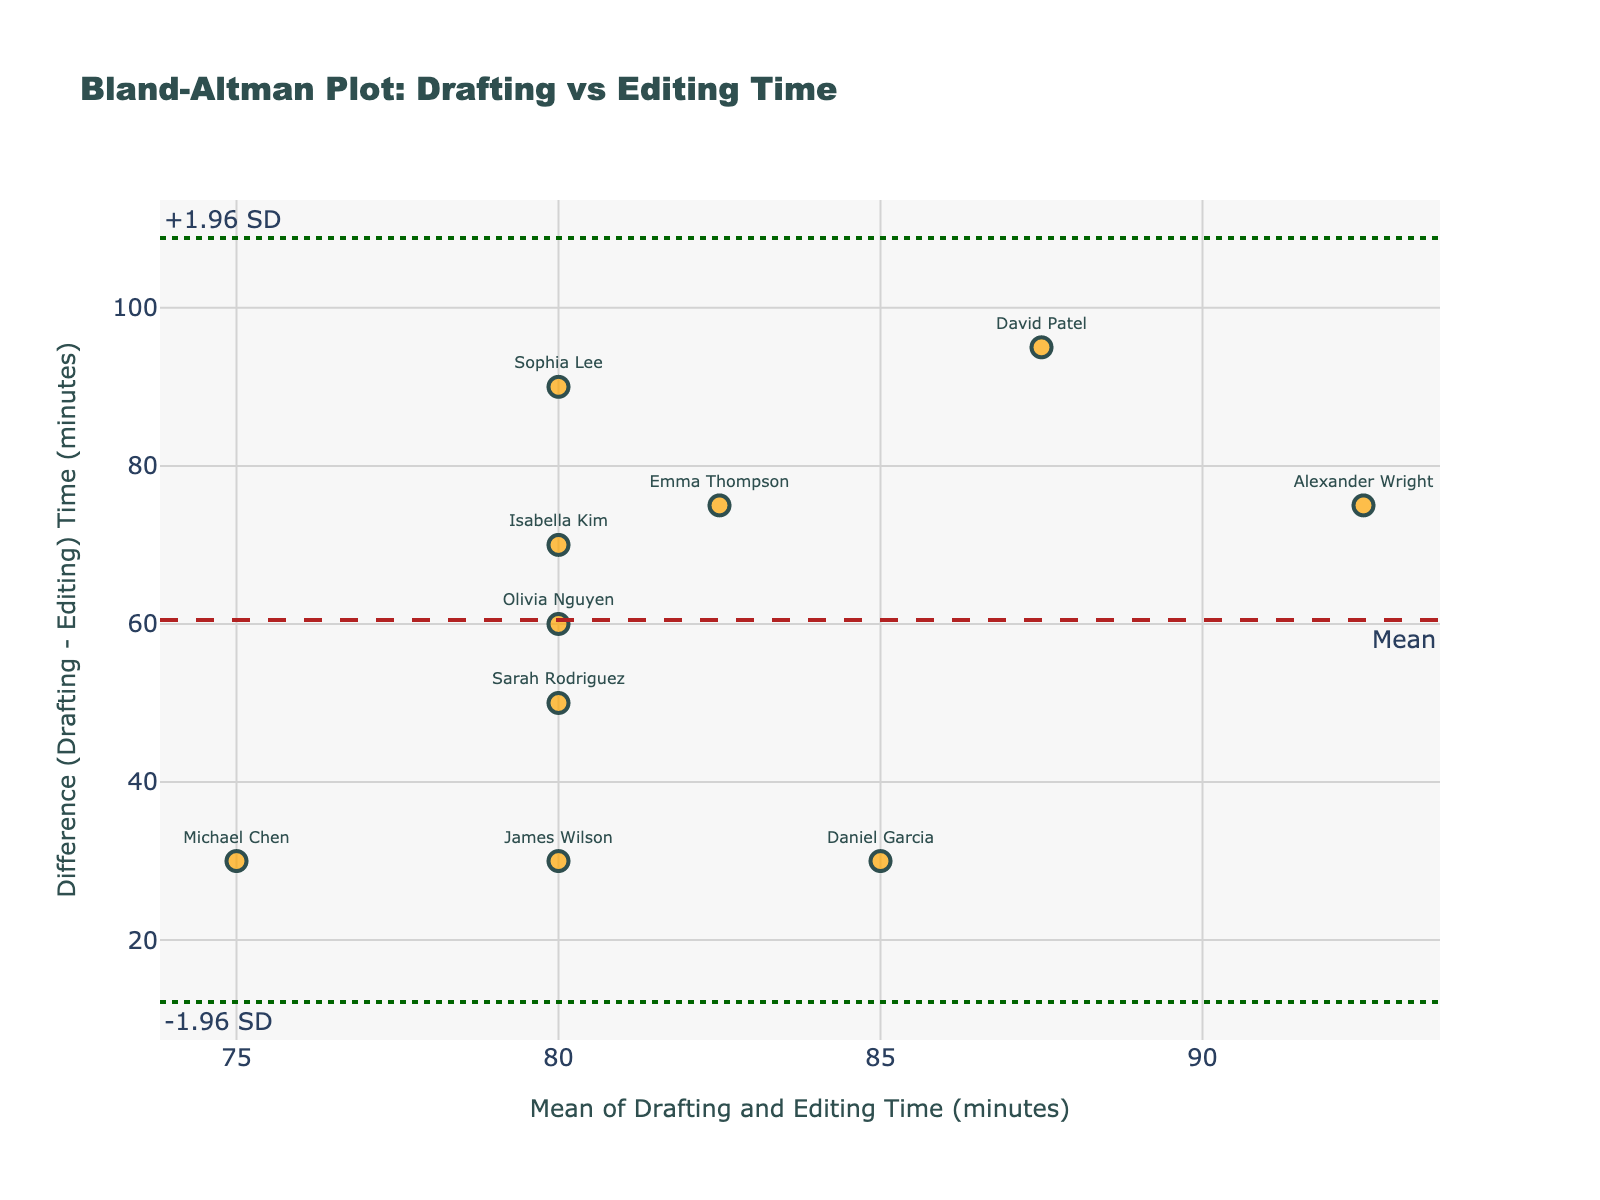What's the title of the figure? The title is displayed at the top of the plot.
Answer: Bland-Altman Plot: Drafting vs Editing Time How many data points are shown in the plot? Each data point corresponds to a name listed in the data, so simply count the names.
Answer: 10 Which data point has the largest difference between drafting and editing times? Identify the point with the highest value on the y-axis for the 'Difference' (Drafting - Editing) times.
Answer: David Patel Which data point lies closest to the mean difference line? This is the point that is closest to the horizontal dashed 'Mean' line in the middle of the plot.
Answer: Sarah Rodriguez What's the mean of 'DraftingTime' and 'EditingTime' for Sophia Lee? Calculate the average of Sophia Lee's drafting and editing times: (125 + 35)/2.
Answer: 80 What's the value of the mean difference (Drafting - Editing) time? The mean difference is shown as a horizontal dashed line annotated with 'Mean.'
Answer: Around 48 Which data points fall outside the limits of agreement? Look for points that are above the '+1.96 SD' line or below the '-1.96 SD' line.
Answer: None How do the editing times compare to the drafting times for all members? For each data point, check if the difference is positive (drafting takes longer) or negative. All data points are above the x-axis, indicating drafting time is greater.
Answer: Drafting time is always longer What's unique about Daniel Garcia's position compared to others? Compare his position based on both the mean value (x-axis) and difference (y-axis).
Answer: He has the highest mean time and second largest difference How are the limits of agreement calculated on this plot? To get this, multiply the standard deviation of differences by 1.96 and add/subtract from the mean difference, shown by the dotted lines. For \( \text{sd} \approx 10 \), limits are approximately \( 48 \pm 19.6 \).
Answer: Around 28.4 to 67.6 